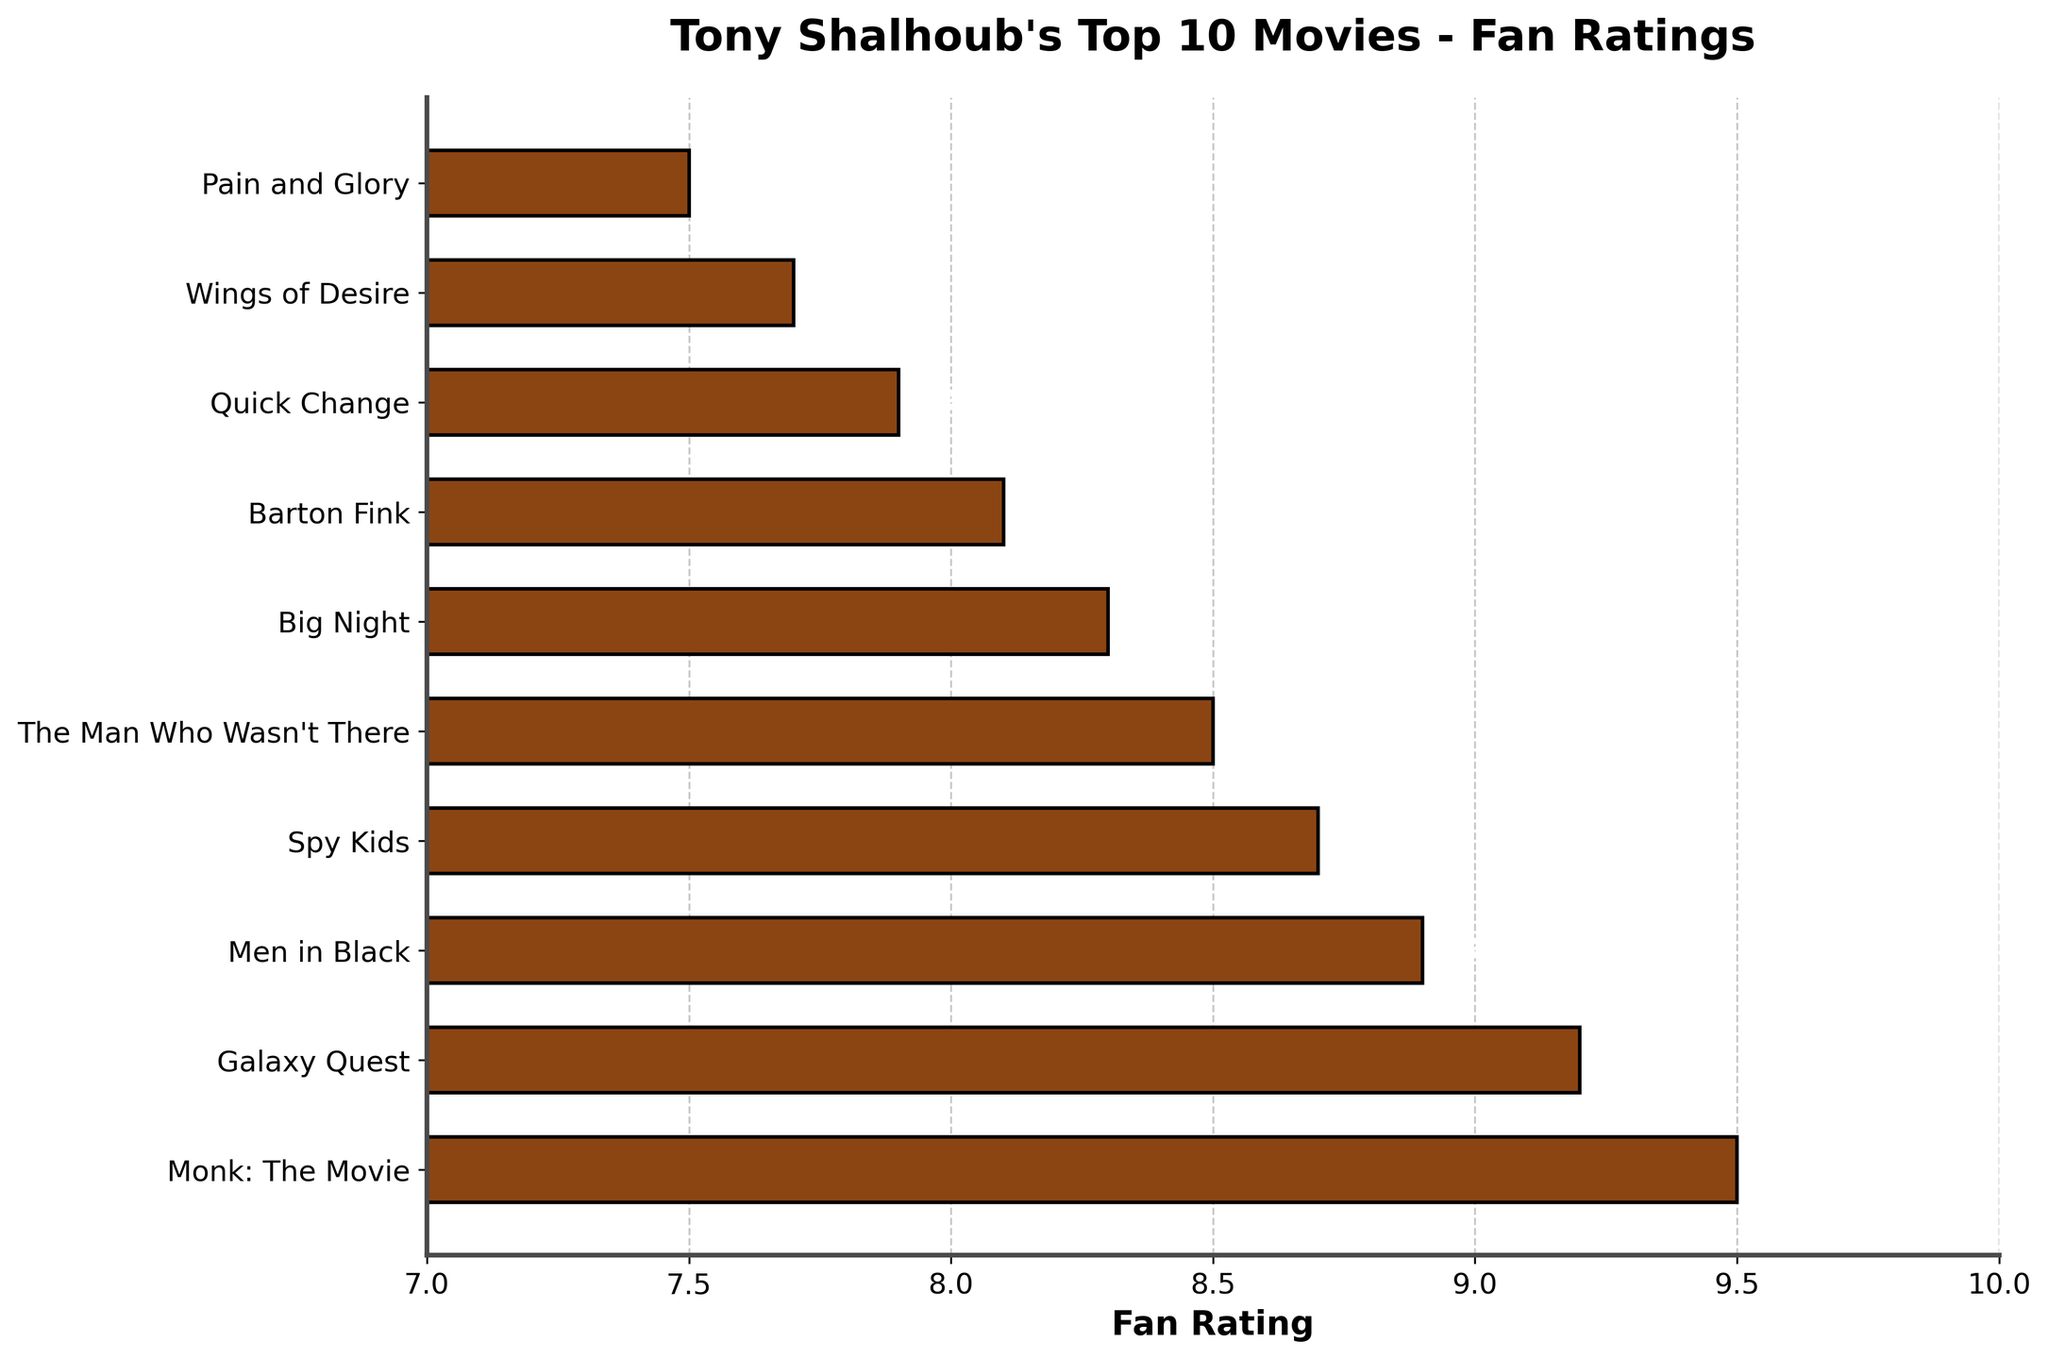Which movie has the highest fan rating? The movie with the highest fan rating can be identified as the bar with the longest length. "Monk: The Movie" has the longest bar indicating a rating of 9.5.
Answer: Monk: The Movie How many movies have a fan rating greater than 9? By observing the bars, you can count the movies with ratings extending beyond the mark of 9 on the x-axis. There are 2 movies with ratings above 9: "Monk: The Movie" (9.5) and "Galaxy Quest" (9.2).
Answer: 2 What is the difference in fan ratings between "Men in Black" and "Pain and Glory"? To find the difference, subtract the rating of "Pain and Glory" (7.5) from the rating of "Men in Black" (8.9). The difference is 8.9 - 7.5 = 1.4.
Answer: 1.4 Which movie has the lowest fan rating and what is that rating? The movie with the shortest bar has the lowest rating. "Pain and Glory" has the shortest bar with a rating of 7.5.
Answer: Pain and Glory, 7.5 What is the average fan rating of the top 3 movies? The top 3 movies by rating are "Monk: The Movie" (9.5), "Galaxy Quest" (9.2), and "Men in Black" (8.9). Calculate their average: (9.5 + 9.2 + 8.9) / 3 = 27.6 / 3 = 9.2.
Answer: 9.2 How many movies have a rating between 8 and 9? To answer this, count the movies that have bars extending between 8 and 9 on the x-axis: "Men in Black" (8.9), "Spy Kids" (8.7), "The Man Who Wasn't There" (8.5), and "Big Night" (8.3). There are 4 such movies.
Answer: 4 What is the combined rating of "Barton Fink" and "Quick Change"? Add the ratings of "Barton Fink" (8.1) and "Quick Change" (7.9). The combined rating is 8.1 + 7.9 = 16.
Answer: 16 Which movie ranks 5th in fan rating and what is that rating? By ordering the movies from the highest to the lowest rating, the 5th ranked movie is "The Man Who Wasn't There" with a rating of 8.5.
Answer: The Man Who Wasn't There, 8.5 What is the range of the fan ratings (difference between highest and lowest ratings)? The highest rating is 9.5 ("Monk: The Movie") and the lowest rating is 7.5 ("Pain and Glory"). The range is 9.5 - 7.5 = 2.
Answer: 2 How many movies have a rating less than 8? Count the movies with bars that end before the 8 mark on the x-axis: "Quick Change" (7.9), "Wings of Desire" (7.7), and "Pain and Glory" (7.5). There are 3 such movies.
Answer: 3 